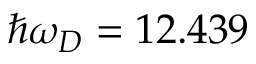<formula> <loc_0><loc_0><loc_500><loc_500>\hbar { \omega } _ { D } = 1 2 . 4 3 9</formula> 